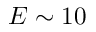<formula> <loc_0><loc_0><loc_500><loc_500>E \sim 1 0</formula> 